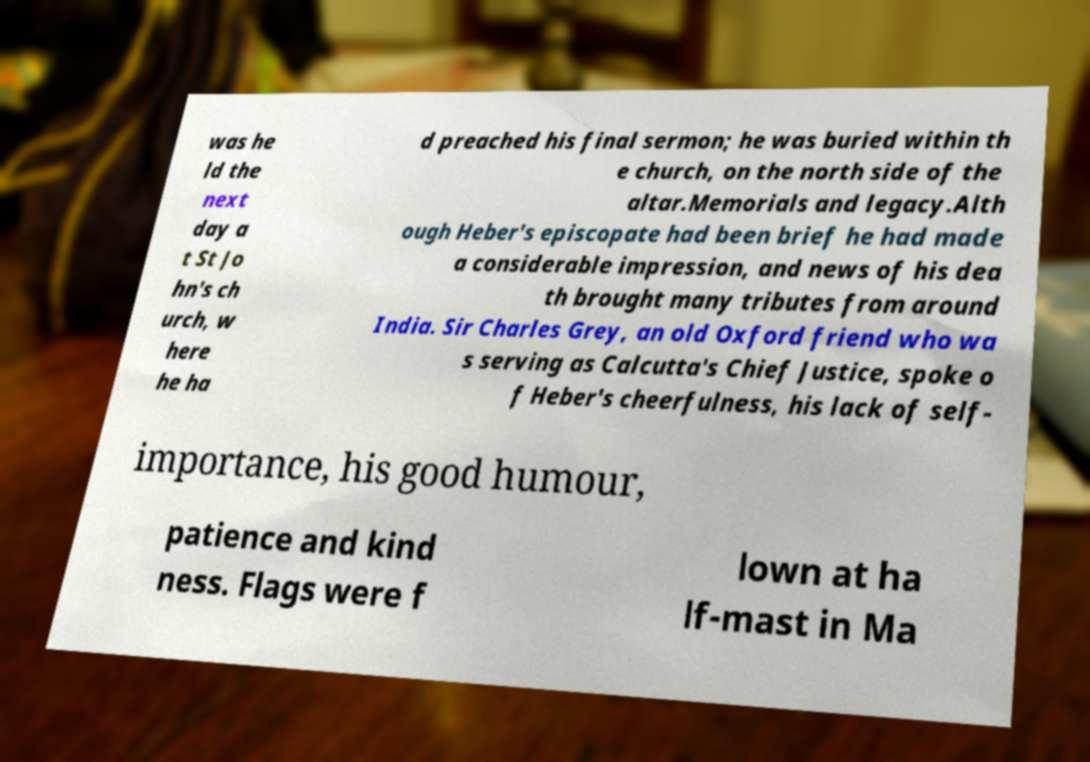What messages or text are displayed in this image? I need them in a readable, typed format. was he ld the next day a t St Jo hn's ch urch, w here he ha d preached his final sermon; he was buried within th e church, on the north side of the altar.Memorials and legacy.Alth ough Heber's episcopate had been brief he had made a considerable impression, and news of his dea th brought many tributes from around India. Sir Charles Grey, an old Oxford friend who wa s serving as Calcutta's Chief Justice, spoke o f Heber's cheerfulness, his lack of self- importance, his good humour, patience and kind ness. Flags were f lown at ha lf-mast in Ma 